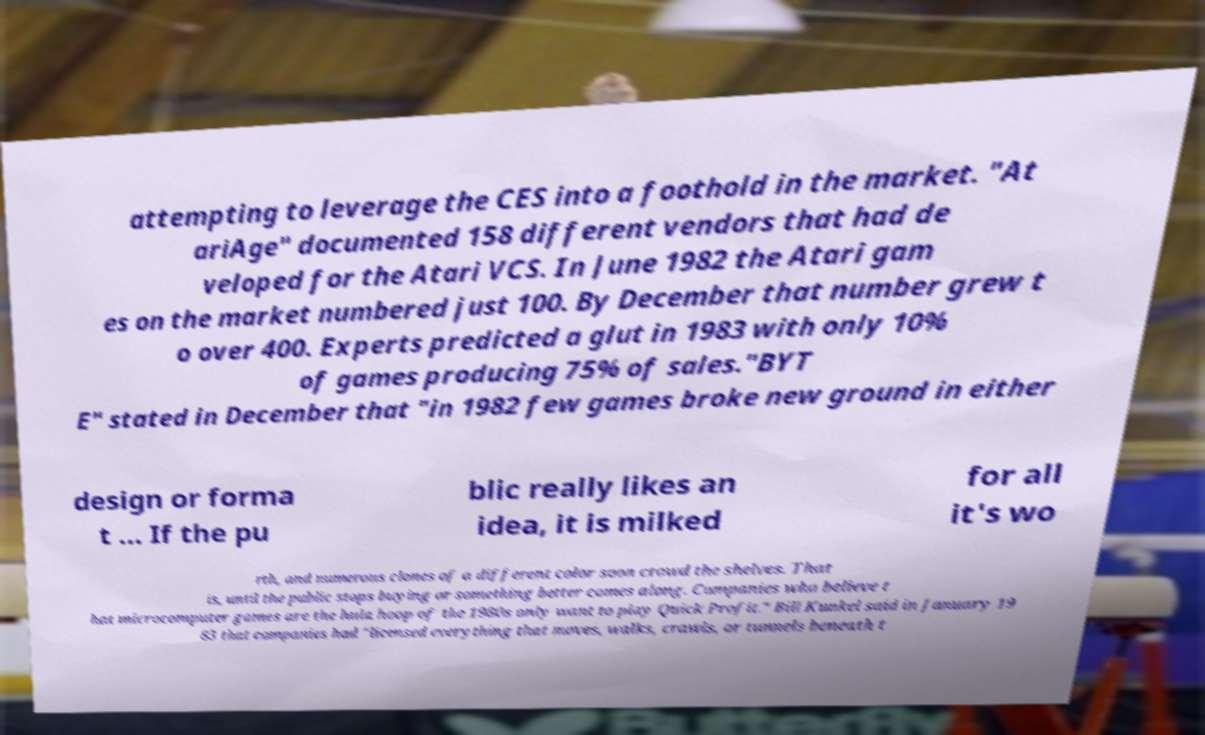Can you accurately transcribe the text from the provided image for me? attempting to leverage the CES into a foothold in the market. "At ariAge" documented 158 different vendors that had de veloped for the Atari VCS. In June 1982 the Atari gam es on the market numbered just 100. By December that number grew t o over 400. Experts predicted a glut in 1983 with only 10% of games producing 75% of sales."BYT E" stated in December that "in 1982 few games broke new ground in either design or forma t ... If the pu blic really likes an idea, it is milked for all it's wo rth, and numerous clones of a different color soon crowd the shelves. That is, until the public stops buying or something better comes along. Companies who believe t hat microcomputer games are the hula hoop of the 1980s only want to play Quick Profit." Bill Kunkel said in January 19 83 that companies had "licensed everything that moves, walks, crawls, or tunnels beneath t 